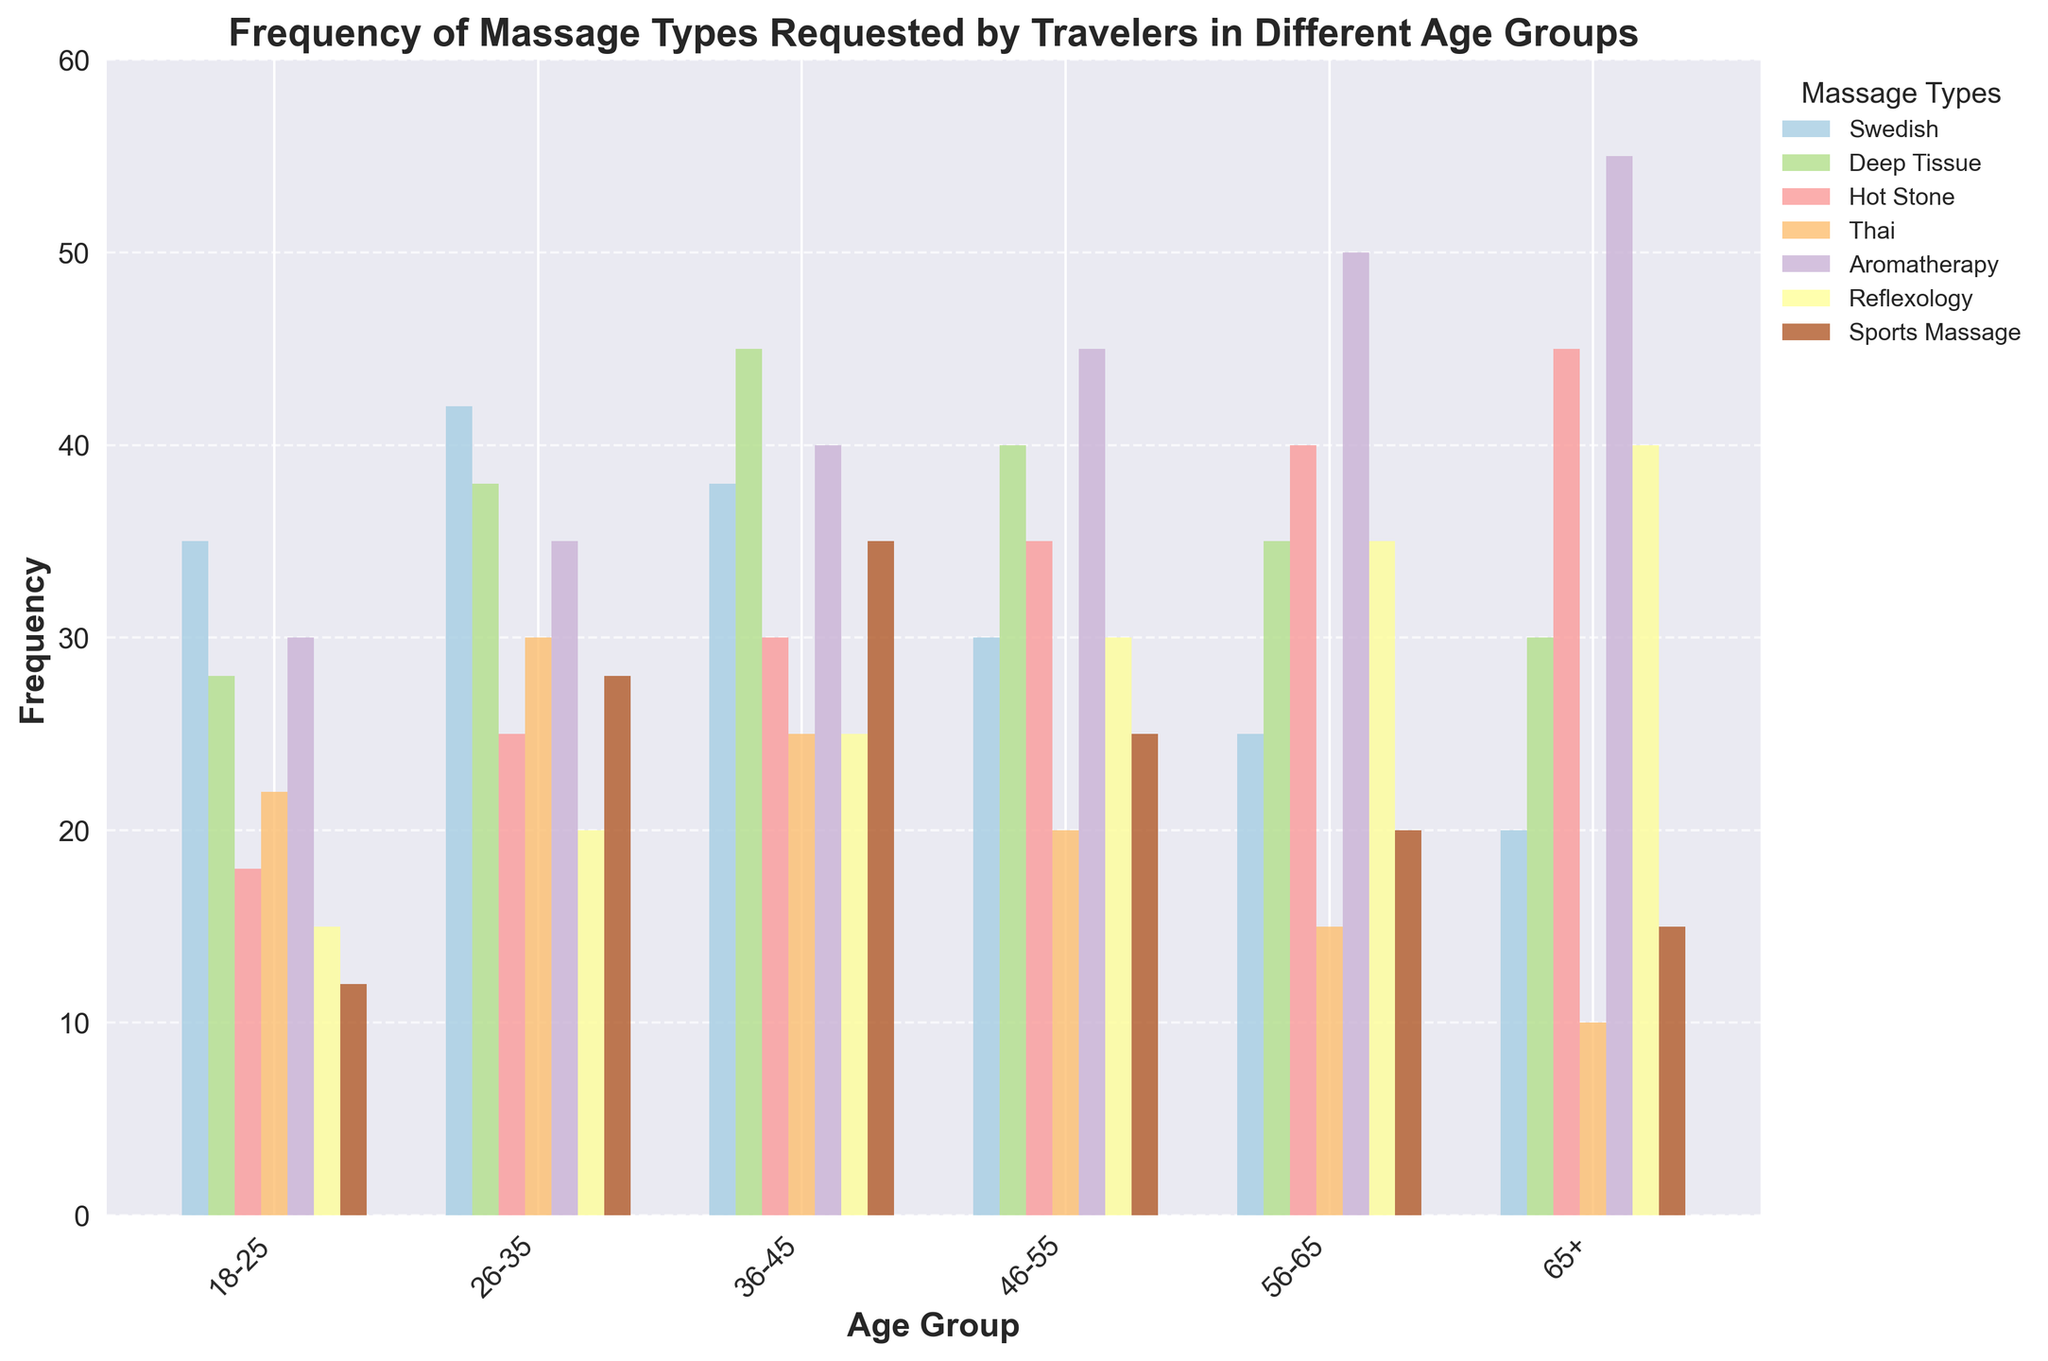What is the most requested massage type by the age group 26-35? By examining the figure, look for the tallest bar within the age group 26-35. The tallest bar represents the most requested massage type for that age group.
Answer: Deep Tissue Which age group requests Hot Stone massages the least? Identify the smallest bar among the bars representing Hot Stone massages. The smallest bar corresponds to the age group with the least requests for Hot Stone massages.
Answer: 18-25 Between the age groups 36-45 and 56-65, which one prefers Aromatherapy massages more? Compare the height of the Aromatherapy bars for both age groups. The taller bar indicates a higher preference for Aromatherapy massages.
Answer: 56-65 What is the total number of Swedish massages requested by travelers in the age groups 46-55 and 65+ combined? Add the values of the Swedish massages for the age groups 46-55 and 65+. 30 (46-55) + 20 (65+) = 50
Answer: 50 Which massage type has consistent increasing requests across all age groups? Analyze each massage type and observe if there is a consistent increase in bar height across the age groups.
Answer: Aromatherapy What is the average frequency of Sports Massage requests for age groups 18-25 and 26-35? Calculate the average of Sports Massage requests by adding the values for the age groups 18-25 and 26-35, then dividing by 2. (12 + 28) / 2 = 20
Answer: 20 By how many requests does Reflexology for age group 46-55 exceed the requests for age group 26-35? Subtract the value of Reflexology for the age group 26-35 from the value of Reflexology for the age group 46-55. 30 (46-55) - 20 (26-35) = 10
Answer: 10 Which age group has the highest overall frequency of requesting massages? Sum the frequencies of all massage types for each age group and compare them to find the highest total.
Answer: 26-35 What is the difference between the highest and lowest frequency of Thai massages requested? Identify the highest and lowest values for Thai massages and find their difference. 30 (highest) - 10 (lowest) = 20
Answer: 20 